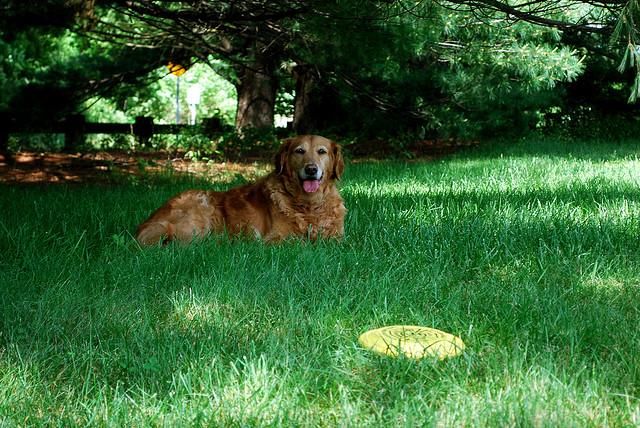Is the dog in the shade?
Give a very brief answer. Yes. What toy is near the dog?
Be succinct. Frisbee. What is the dog laying on?
Short answer required. Grass. 